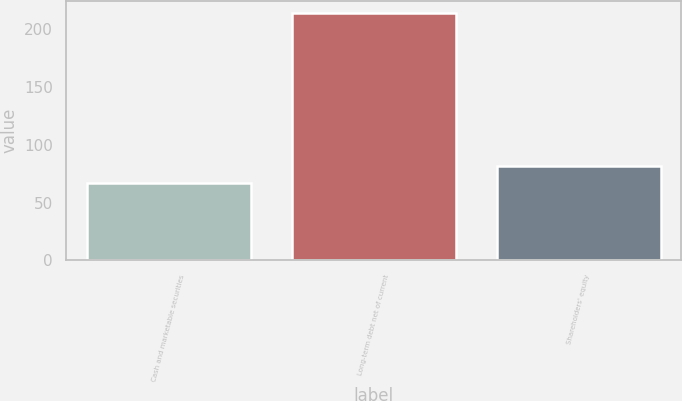<chart> <loc_0><loc_0><loc_500><loc_500><bar_chart><fcel>Cash and marketable securities<fcel>Long-term debt net of current<fcel>Shareholders' equity<nl><fcel>67.3<fcel>214<fcel>81.97<nl></chart> 